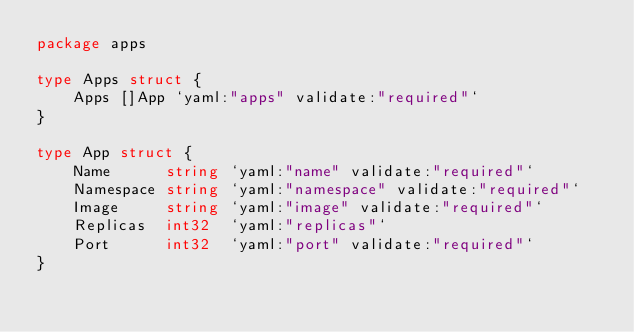Convert code to text. <code><loc_0><loc_0><loc_500><loc_500><_Go_>package apps

type Apps struct {
	Apps []App `yaml:"apps" validate:"required"`
}

type App struct {
	Name      string `yaml:"name" validate:"required"`
	Namespace string `yaml:"namespace" validate:"required"`
	Image     string `yaml:"image" validate:"required"`
	Replicas  int32  `yaml:"replicas"`
	Port      int32  `yaml:"port" validate:"required"`
}

</code> 